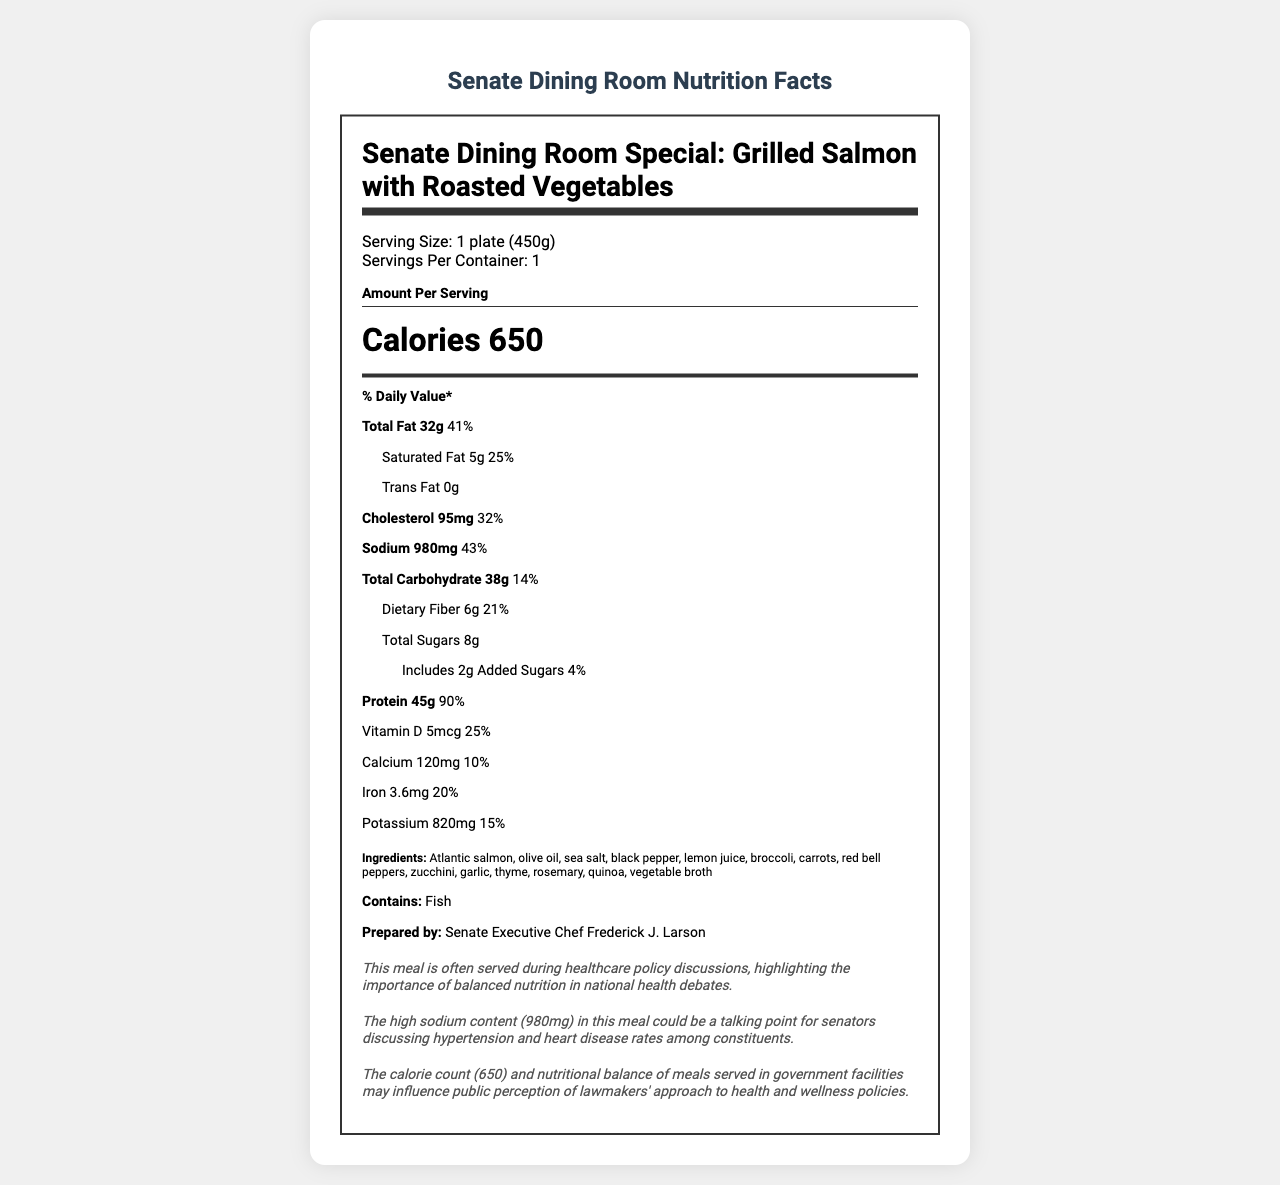What is the serving size of the Senate Dining Room Special: Grilled Salmon with Roasted Vegetables? The document states that the serving size is "1 plate (450g)."
Answer: 1 plate (450g) How many calories are in one serving of this meal? The document lists the calories per serving as 650.
Answer: 650 calories What is the amount of sodium in this meal measured in milligrams? The sodium content for this meal is listed as 980 mg in the document.
Answer: 980 mg What is the percentage of the daily value of protein provided by this meal? The document indicates that one serving provides 90% of the daily value of protein.
Answer: 90% List three ingredients found in this dish. The ingredients listed in the document include Atlantic salmon, olive oil, sea salt, among others.
Answer: Atlantic salmon, olive oil, sea salt Is the total fat content higher than the protein content in this dish? The total fat content is 32g, whereas the protein content is 45g; thus, protein content is higher.
Answer: No Which of the following nutrients has the highest daily value percentage? A. Vitamin D B. Iron C. Protein D. Sodium Protein has the highest daily value percentage at 90%, followed by sodium at 43%, iron at 20%, and Vitamin D at 25%.
Answer: C. Protein Which of the following allergens is present in this dish? A. Tree nuts B. Peanuts C. Fish D. Dairy The document clearly states that the allergens include "Fish."
Answer: C. Fish Does this meal contain trans fat? The document specifies that the trans fat content is 0g.
Answer: No Summarize the main idea of the document. The document outlines the serving size, calories, and various nutrient amounts along with their daily value percentages. It also highlights the potential healthcare impact of the meal, particularly related to sodium content, and mentions its significance in the context of health policy discussions.
Answer: The document provides the nutrition facts for the Senate Dining Room Special: Grilled Salmon with Roasted Vegetables, focusing on its calorie count, nutrient content, and healthcare context. What is the political context mentioned for this meal? The document states that the meal is served during healthcare policy discussions but does not provide detailed political context.
Answer: Not enough information What is the total amount of dietary fiber in this meal? The document lists that the total dietary fiber content is 6g.
Answer: 6g 